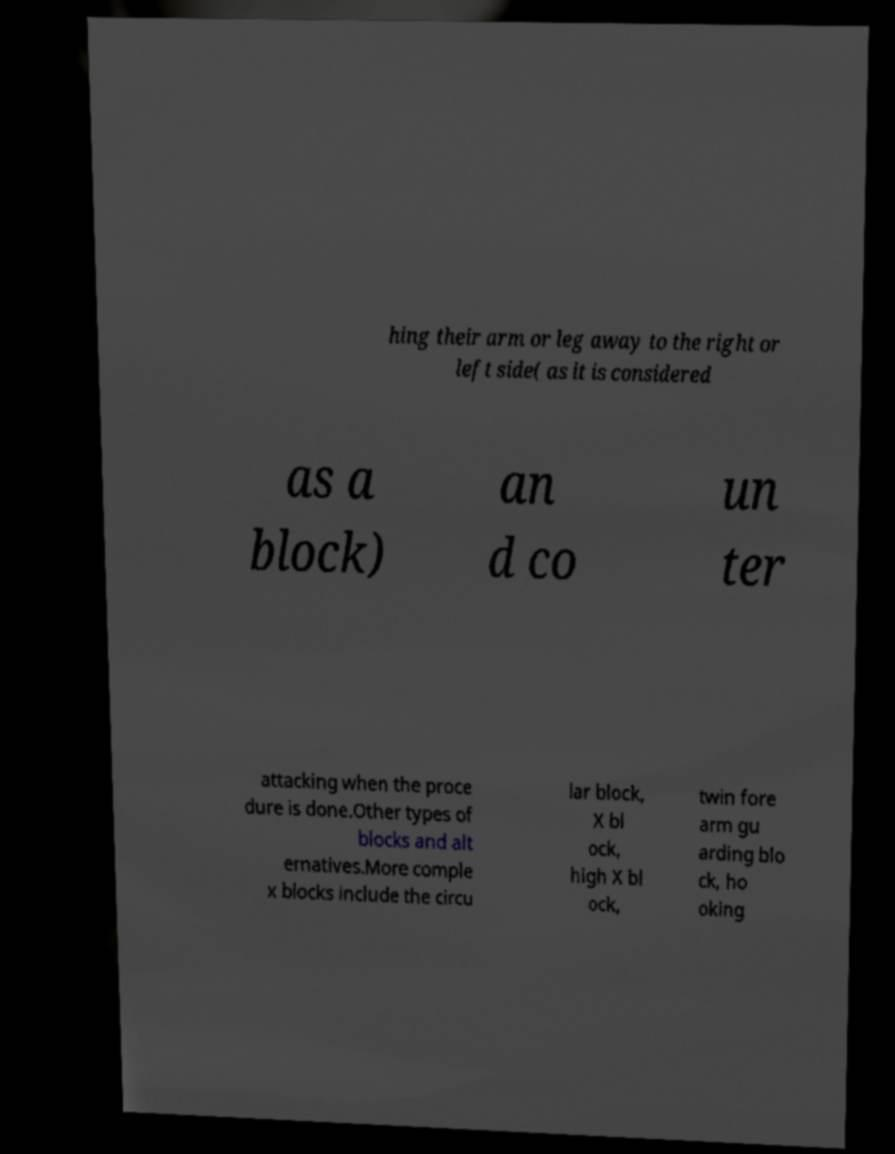Could you extract and type out the text from this image? hing their arm or leg away to the right or left side( as it is considered as a block) an d co un ter attacking when the proce dure is done.Other types of blocks and alt ernatives.More comple x blocks include the circu lar block, X bl ock, high X bl ock, twin fore arm gu arding blo ck, ho oking 